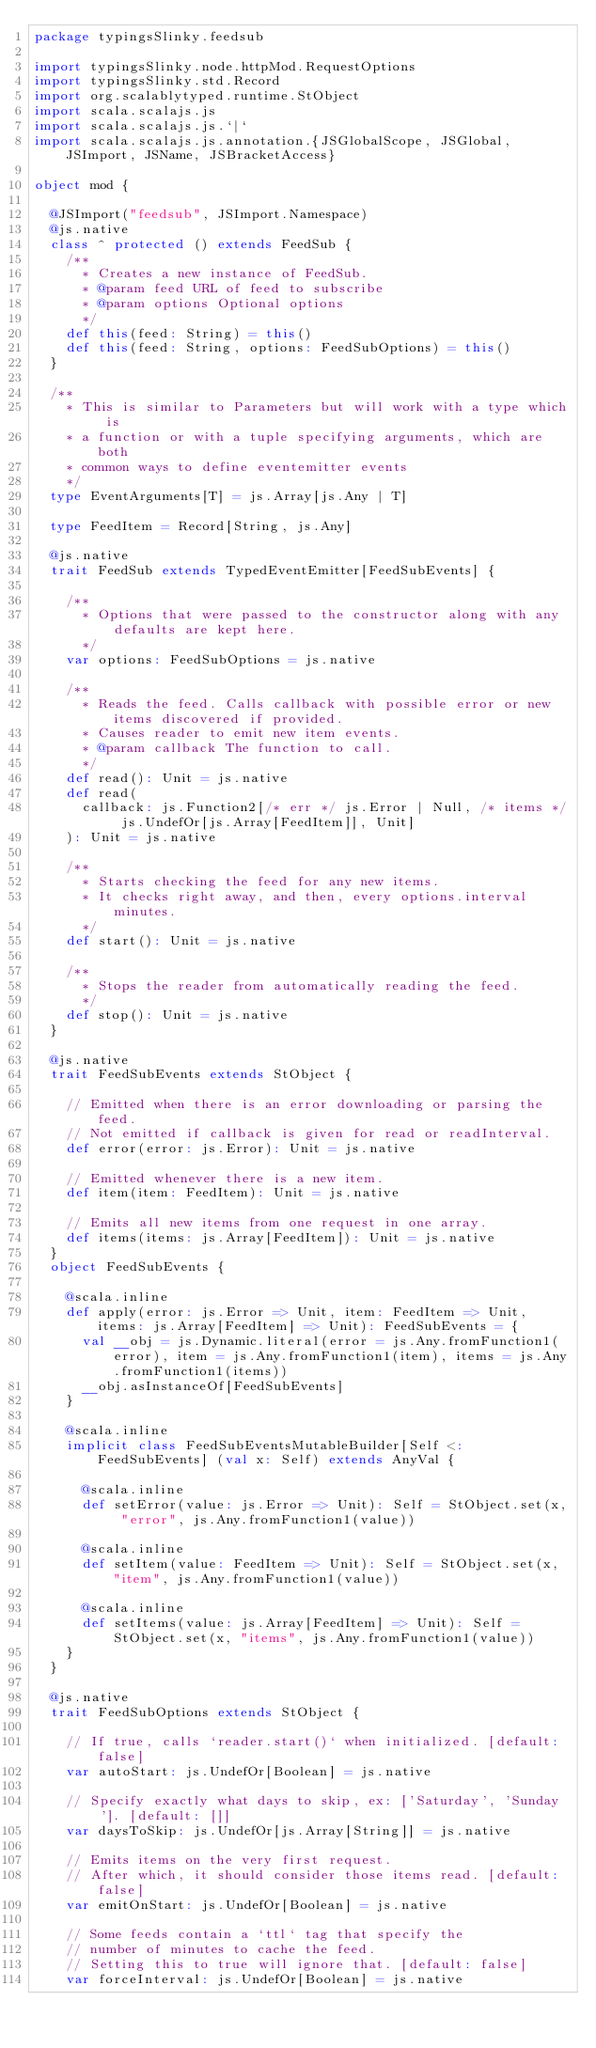<code> <loc_0><loc_0><loc_500><loc_500><_Scala_>package typingsSlinky.feedsub

import typingsSlinky.node.httpMod.RequestOptions
import typingsSlinky.std.Record
import org.scalablytyped.runtime.StObject
import scala.scalajs.js
import scala.scalajs.js.`|`
import scala.scalajs.js.annotation.{JSGlobalScope, JSGlobal, JSImport, JSName, JSBracketAccess}

object mod {
  
  @JSImport("feedsub", JSImport.Namespace)
  @js.native
  class ^ protected () extends FeedSub {
    /**
      * Creates a new instance of FeedSub.
      * @param feed URL of feed to subscribe
      * @param options Optional options
      */
    def this(feed: String) = this()
    def this(feed: String, options: FeedSubOptions) = this()
  }
  
  /**
    * This is similar to Parameters but will work with a type which is
    * a function or with a tuple specifying arguments, which are both
    * common ways to define eventemitter events
    */
  type EventArguments[T] = js.Array[js.Any | T]
  
  type FeedItem = Record[String, js.Any]
  
  @js.native
  trait FeedSub extends TypedEventEmitter[FeedSubEvents] {
    
    /**
      * Options that were passed to the constructor along with any defaults are kept here.
      */
    var options: FeedSubOptions = js.native
    
    /**
      * Reads the feed. Calls callback with possible error or new items discovered if provided.
      * Causes reader to emit new item events.
      * @param callback The function to call.
      */
    def read(): Unit = js.native
    def read(
      callback: js.Function2[/* err */ js.Error | Null, /* items */ js.UndefOr[js.Array[FeedItem]], Unit]
    ): Unit = js.native
    
    /**
      * Starts checking the feed for any new items.
      * It checks right away, and then, every options.interval minutes.
      */
    def start(): Unit = js.native
    
    /**
      * Stops the reader from automatically reading the feed.
      */
    def stop(): Unit = js.native
  }
  
  @js.native
  trait FeedSubEvents extends StObject {
    
    // Emitted when there is an error downloading or parsing the feed.
    // Not emitted if callback is given for read or readInterval.
    def error(error: js.Error): Unit = js.native
    
    // Emitted whenever there is a new item.
    def item(item: FeedItem): Unit = js.native
    
    // Emits all new items from one request in one array.
    def items(items: js.Array[FeedItem]): Unit = js.native
  }
  object FeedSubEvents {
    
    @scala.inline
    def apply(error: js.Error => Unit, item: FeedItem => Unit, items: js.Array[FeedItem] => Unit): FeedSubEvents = {
      val __obj = js.Dynamic.literal(error = js.Any.fromFunction1(error), item = js.Any.fromFunction1(item), items = js.Any.fromFunction1(items))
      __obj.asInstanceOf[FeedSubEvents]
    }
    
    @scala.inline
    implicit class FeedSubEventsMutableBuilder[Self <: FeedSubEvents] (val x: Self) extends AnyVal {
      
      @scala.inline
      def setError(value: js.Error => Unit): Self = StObject.set(x, "error", js.Any.fromFunction1(value))
      
      @scala.inline
      def setItem(value: FeedItem => Unit): Self = StObject.set(x, "item", js.Any.fromFunction1(value))
      
      @scala.inline
      def setItems(value: js.Array[FeedItem] => Unit): Self = StObject.set(x, "items", js.Any.fromFunction1(value))
    }
  }
  
  @js.native
  trait FeedSubOptions extends StObject {
    
    // If true, calls `reader.start()` when initialized. [default: false]
    var autoStart: js.UndefOr[Boolean] = js.native
    
    // Specify exactly what days to skip, ex: ['Saturday', 'Sunday']. [default: []]
    var daysToSkip: js.UndefOr[js.Array[String]] = js.native
    
    // Emits items on the very first request.
    // After which, it should consider those items read. [default: false]
    var emitOnStart: js.UndefOr[Boolean] = js.native
    
    // Some feeds contain a `ttl` tag that specify the
    // number of minutes to cache the feed.
    // Setting this to true will ignore that. [default: false]
    var forceInterval: js.UndefOr[Boolean] = js.native
    </code> 